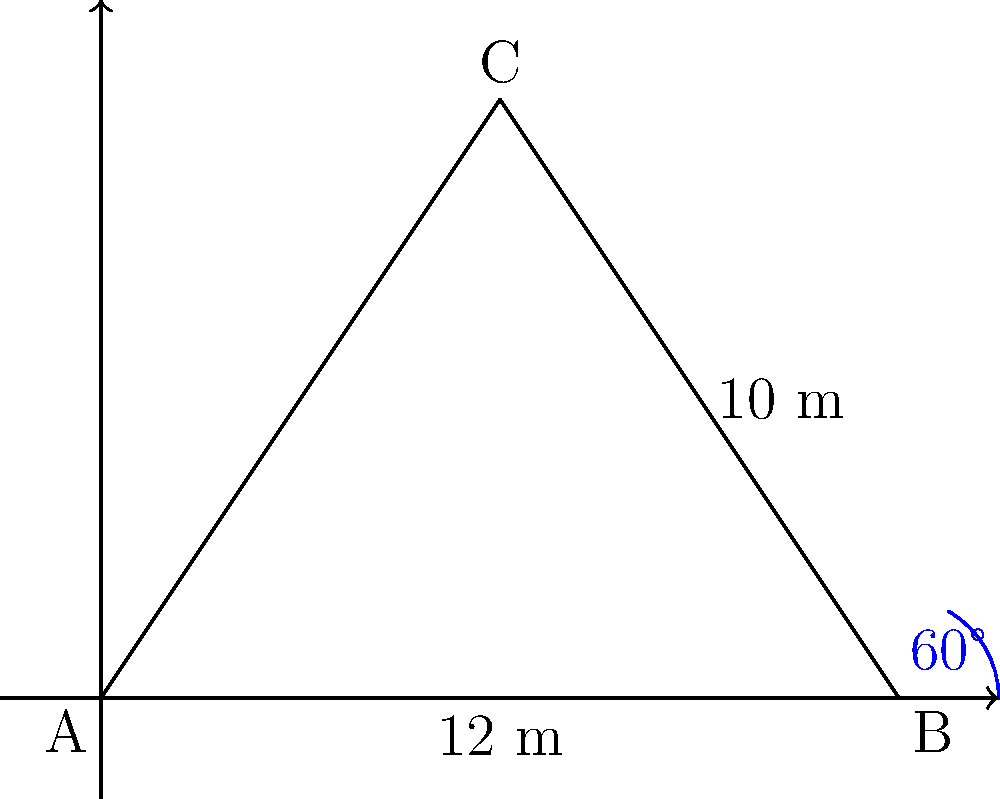At the premiere of Suraj Venjaramoodu's latest film, a unique triangular movie screen is installed. Two sides of the screen measure 12 meters and 10 meters, with an angle of 60° between them. Calculate the area of this triangular screen in square meters. To find the area of the triangular screen, we can use the formula for the area of a triangle given two sides and the included angle:

$$A = \frac{1}{2} ab \sin C$$

Where:
$A$ = Area of the triangle
$a$ and $b$ = Two known sides
$C$ = Angle between the known sides

Given:
$a = 12$ meters
$b = 10$ meters
$C = 60°$

Step 1: Substitute the values into the formula:
$$A = \frac{1}{2} \cdot 12 \cdot 10 \cdot \sin 60°$$

Step 2: Simplify:
$$A = 60 \cdot \sin 60°$$

Step 3: Calculate $\sin 60°$:
$\sin 60° = \frac{\sqrt{3}}{2}$

Step 4: Substitute and calculate:
$$A = 60 \cdot \frac{\sqrt{3}}{2} = 30\sqrt{3}$$

Therefore, the area of the triangular movie screen is $30\sqrt{3}$ square meters.
Answer: $30\sqrt{3}$ m² 